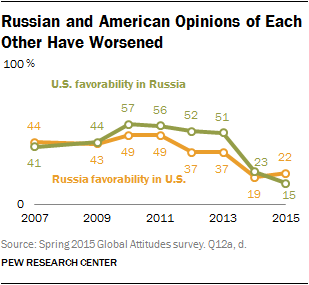Draw attention to some important aspects in this diagram. The sum of the highest and lowest values in the orange graph is greater than 60. The largest value of the green bar is not 30. 